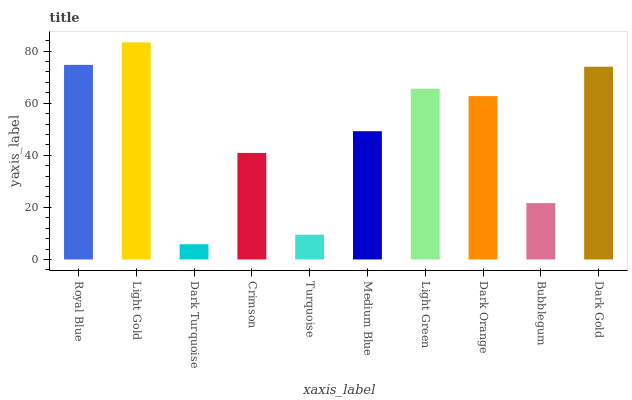Is Light Gold the minimum?
Answer yes or no. No. Is Dark Turquoise the maximum?
Answer yes or no. No. Is Light Gold greater than Dark Turquoise?
Answer yes or no. Yes. Is Dark Turquoise less than Light Gold?
Answer yes or no. Yes. Is Dark Turquoise greater than Light Gold?
Answer yes or no. No. Is Light Gold less than Dark Turquoise?
Answer yes or no. No. Is Dark Orange the high median?
Answer yes or no. Yes. Is Medium Blue the low median?
Answer yes or no. Yes. Is Light Gold the high median?
Answer yes or no. No. Is Crimson the low median?
Answer yes or no. No. 